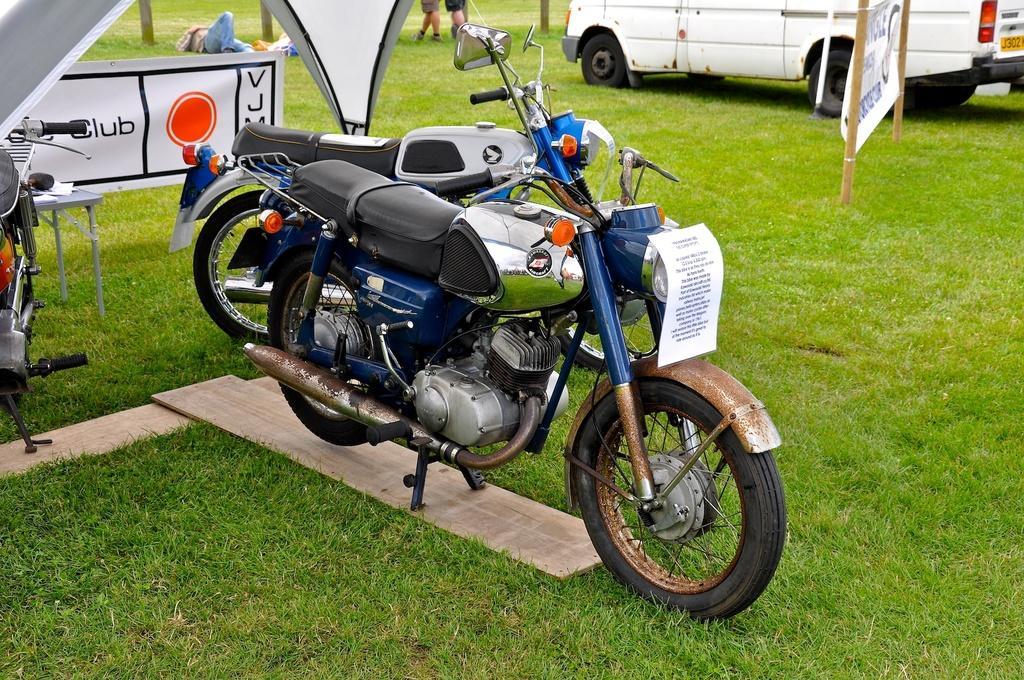In one or two sentences, can you explain what this image depicts? In this image there are a few bikes and vehicles are parked on the surface of the grass, there are a few wooden bricks and banners, there is a table beneath the camp and there are a few people walking and one person is lying. 